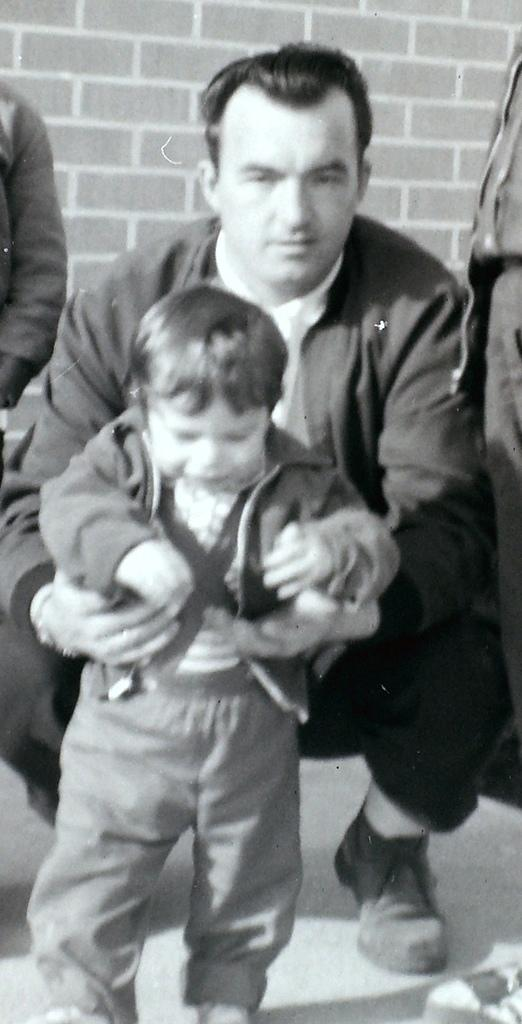Who is the main subject in the image? There is a man in the image. What is the man wearing? The man is wearing a black suit. What is the man doing in the image? The man is holding a small boy. What can be seen in the background of the image? There is a brick texture wall in the background of the image. What is the cause of the hot development in the image? There is no mention of "hot development" in the image; the image features a man in a black suit holding a small boy in front of a brick texture wall. 